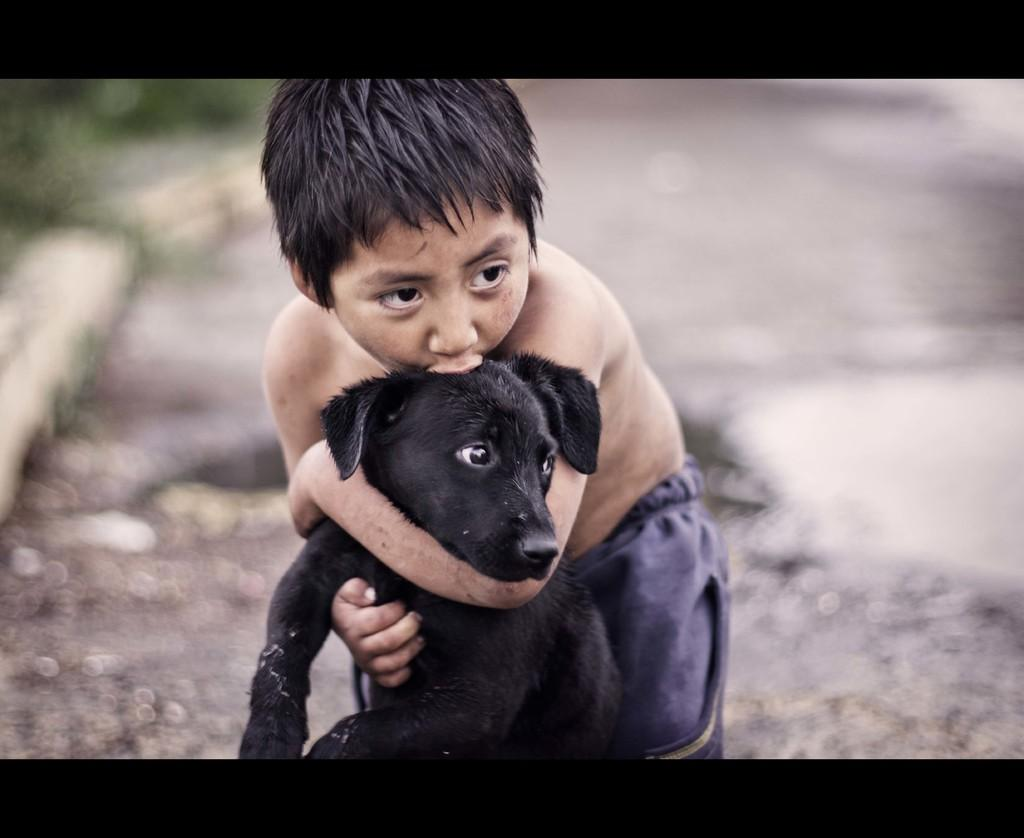What can be observed about the background of the image? The background of the image is blurry. Who is present in the image? There is a boy in the image. What is the boy doing in the image? The boy is playing with a dog. What is the color of the dog in the image? The dog is black in color. What type of cherries can be seen in the image? There are no cherries present in the image. What is the boy's journey in the image? The image does not depict a journey; it shows the boy playing with a dog. 